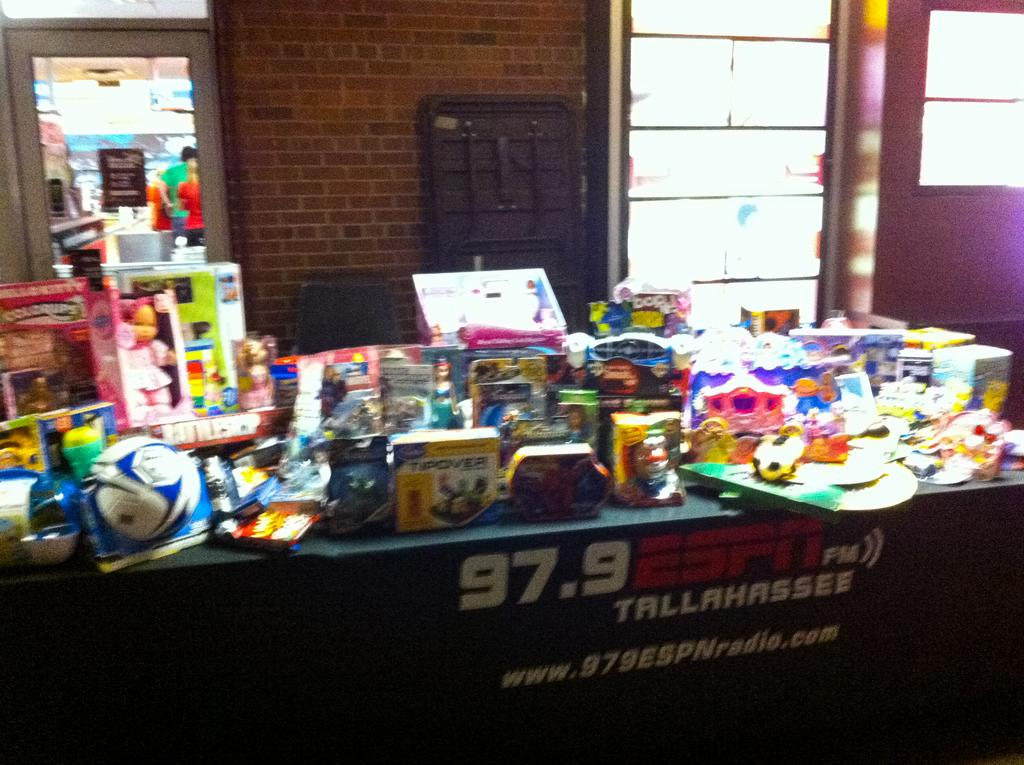<image>
Summarize the visual content of the image. A display of items with an advert for the 97.9 Tallahassee radio station. 